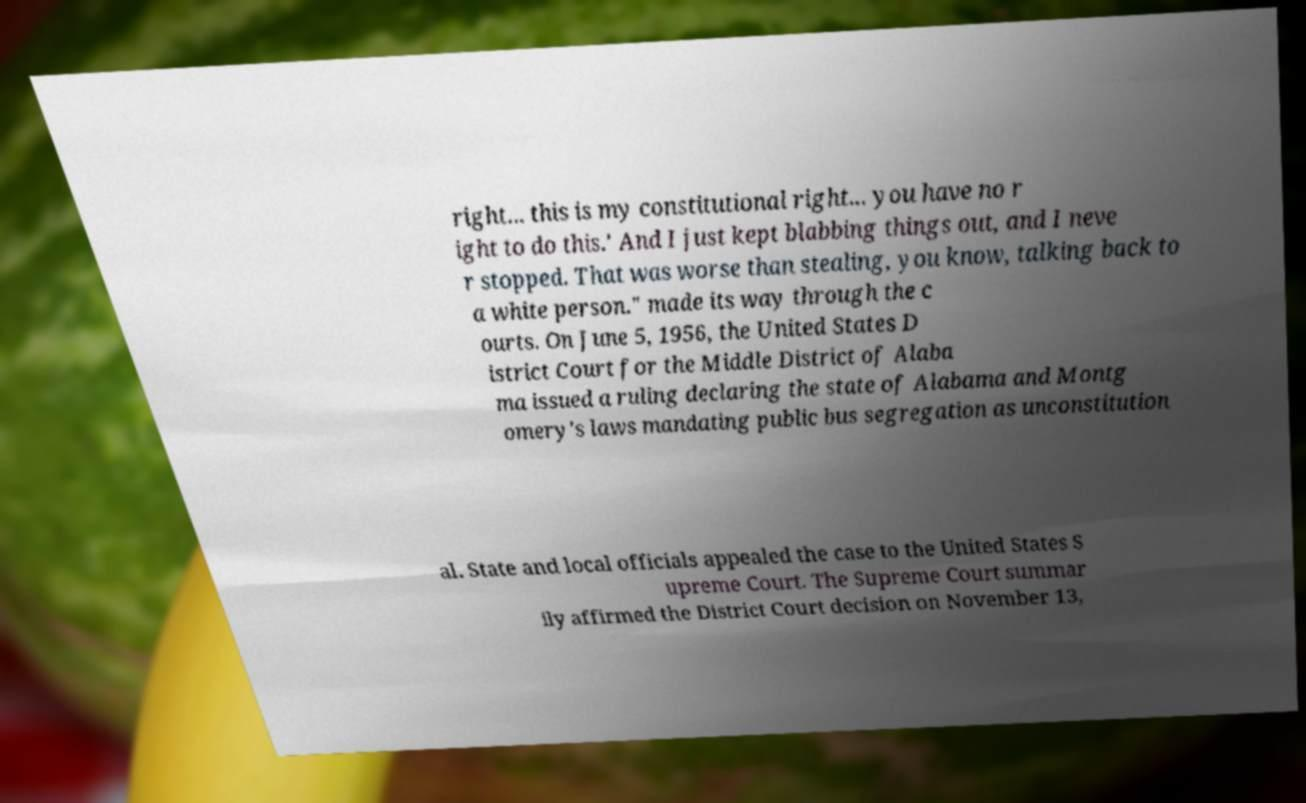Could you extract and type out the text from this image? right... this is my constitutional right... you have no r ight to do this.' And I just kept blabbing things out, and I neve r stopped. That was worse than stealing, you know, talking back to a white person." made its way through the c ourts. On June 5, 1956, the United States D istrict Court for the Middle District of Alaba ma issued a ruling declaring the state of Alabama and Montg omery's laws mandating public bus segregation as unconstitution al. State and local officials appealed the case to the United States S upreme Court. The Supreme Court summar ily affirmed the District Court decision on November 13, 